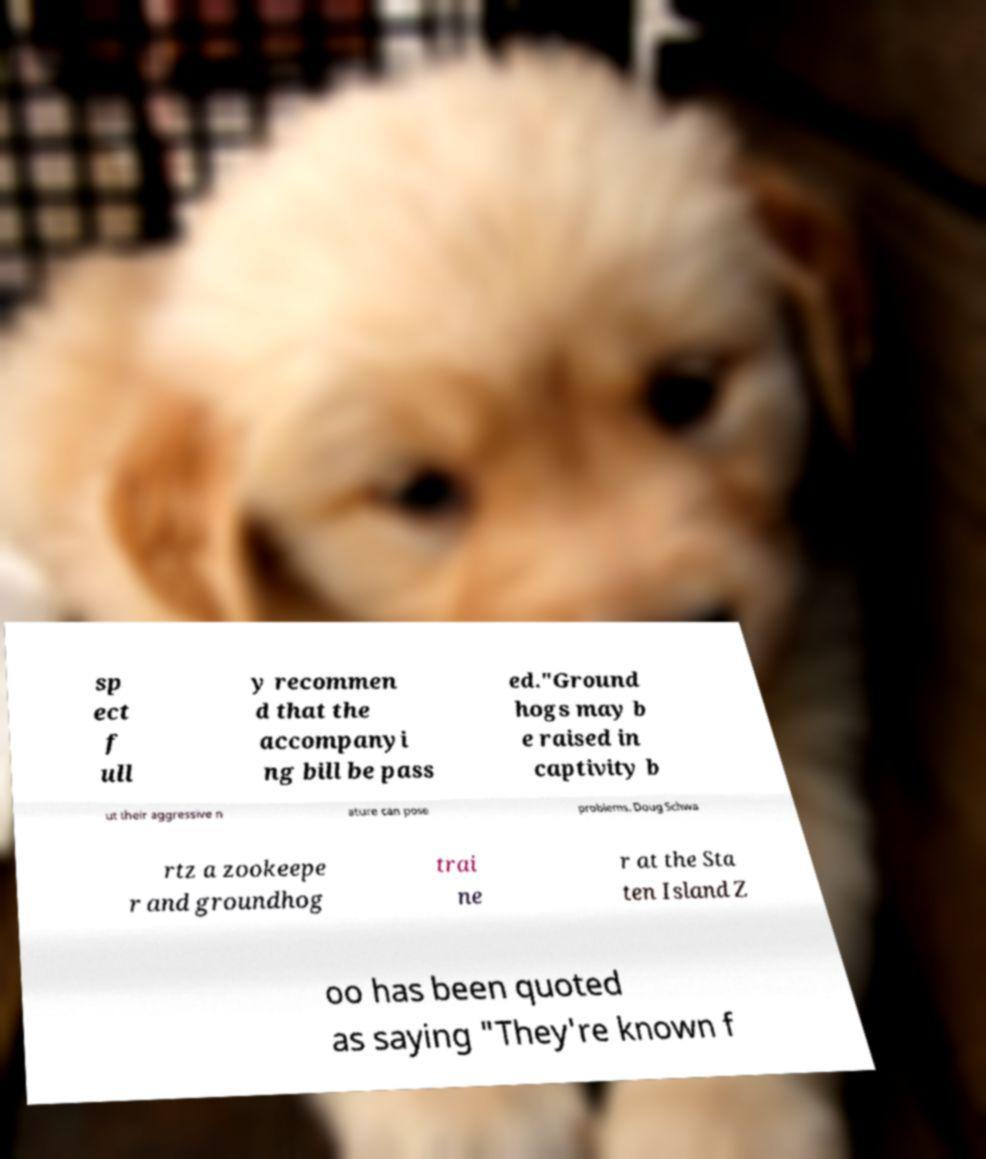Please read and relay the text visible in this image. What does it say? sp ect f ull y recommen d that the accompanyi ng bill be pass ed."Ground hogs may b e raised in captivity b ut their aggressive n ature can pose problems. Doug Schwa rtz a zookeepe r and groundhog trai ne r at the Sta ten Island Z oo has been quoted as saying "They're known f 